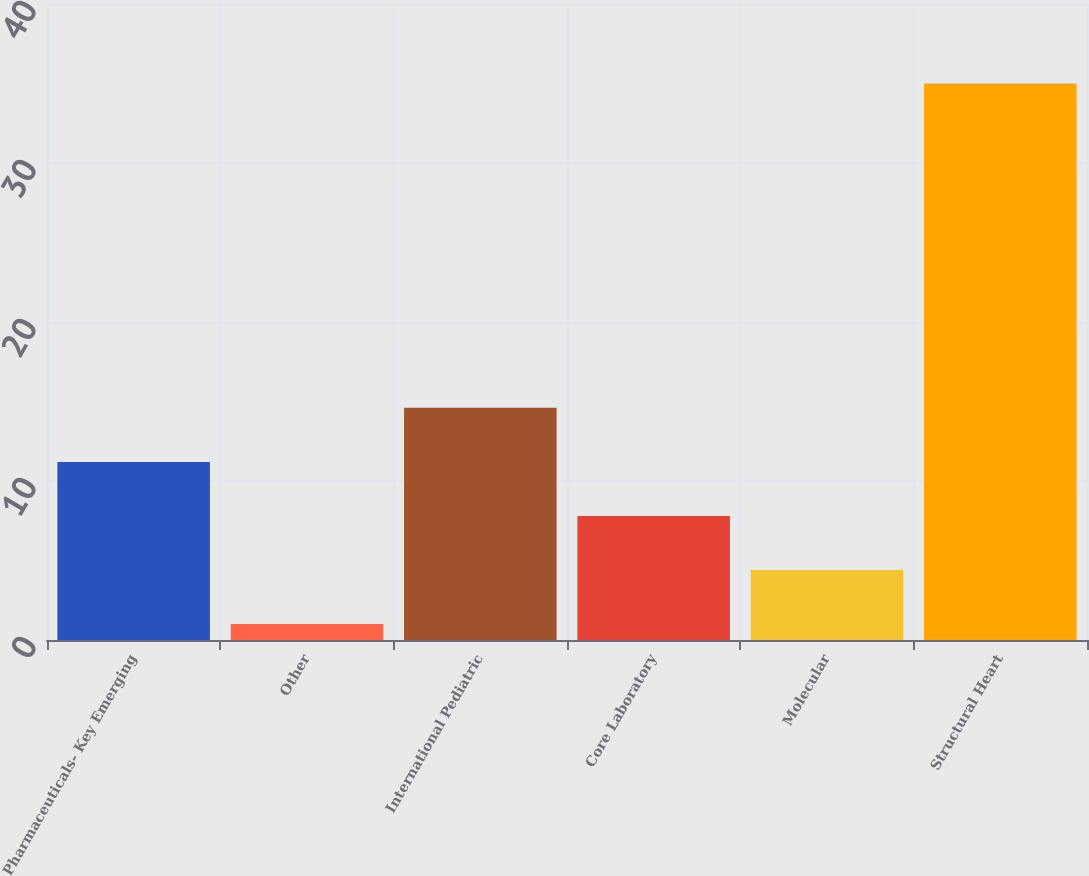Convert chart to OTSL. <chart><loc_0><loc_0><loc_500><loc_500><bar_chart><fcel>Pharmaceuticals- Key Emerging<fcel>Other<fcel>International Pediatric<fcel>Core Laboratory<fcel>Molecular<fcel>Structural Heart<nl><fcel>11.2<fcel>1<fcel>14.6<fcel>7.8<fcel>4.4<fcel>35<nl></chart> 